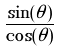Convert formula to latex. <formula><loc_0><loc_0><loc_500><loc_500>\frac { \sin ( \theta ) } { \cos ( \theta ) }</formula> 